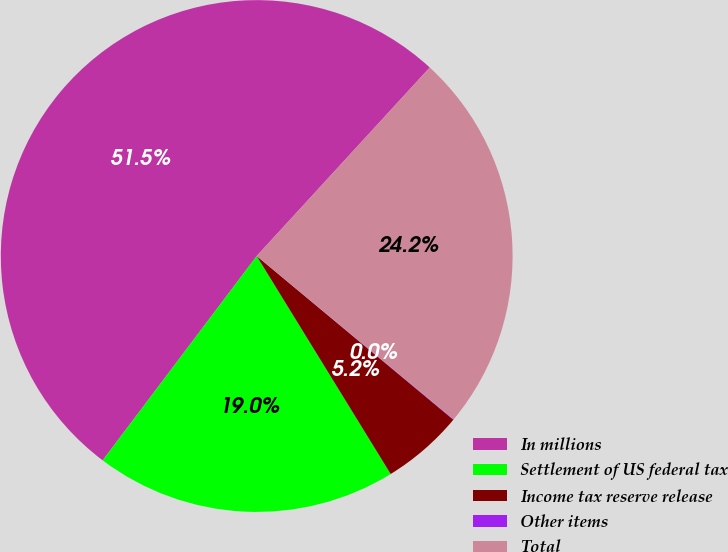<chart> <loc_0><loc_0><loc_500><loc_500><pie_chart><fcel>In millions<fcel>Settlement of US federal tax<fcel>Income tax reserve release<fcel>Other items<fcel>Total<nl><fcel>51.54%<fcel>19.05%<fcel>5.18%<fcel>0.03%<fcel>24.2%<nl></chart> 